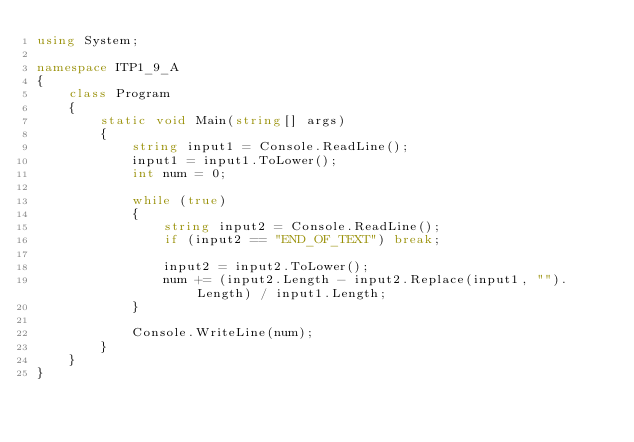Convert code to text. <code><loc_0><loc_0><loc_500><loc_500><_C#_>using System;

namespace ITP1_9_A
{
    class Program
    {
        static void Main(string[] args)
        {
            string input1 = Console.ReadLine();
            input1 = input1.ToLower();
            int num = 0;

            while (true)
            {
                string input2 = Console.ReadLine();
                if (input2 == "END_OF_TEXT") break;

                input2 = input2.ToLower();
                num += (input2.Length - input2.Replace(input1, "").Length) / input1.Length;
            }

            Console.WriteLine(num);
        }
    }
}</code> 